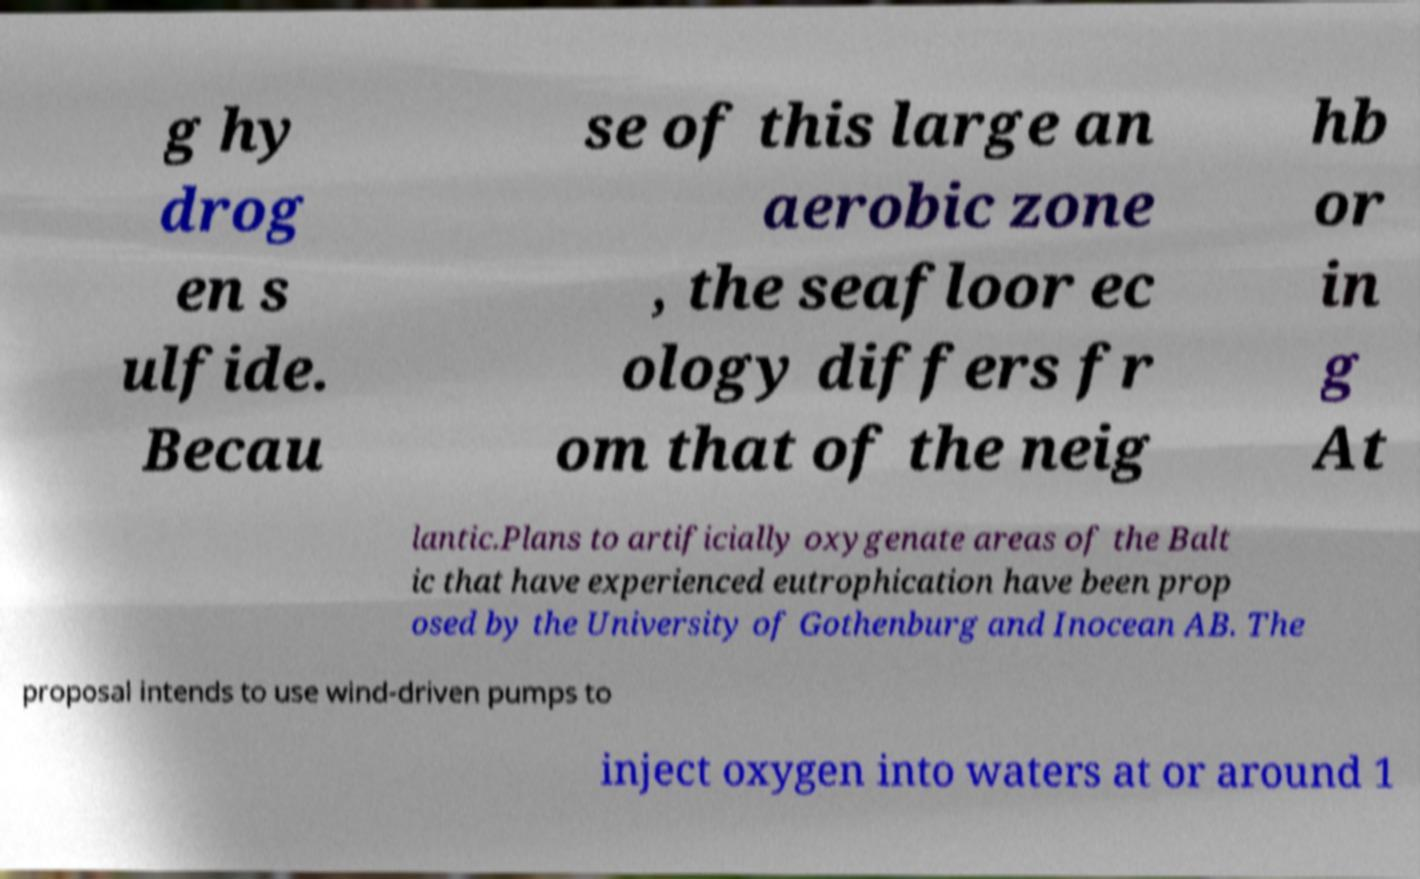Can you read and provide the text displayed in the image?This photo seems to have some interesting text. Can you extract and type it out for me? g hy drog en s ulfide. Becau se of this large an aerobic zone , the seafloor ec ology differs fr om that of the neig hb or in g At lantic.Plans to artificially oxygenate areas of the Balt ic that have experienced eutrophication have been prop osed by the University of Gothenburg and Inocean AB. The proposal intends to use wind-driven pumps to inject oxygen into waters at or around 1 